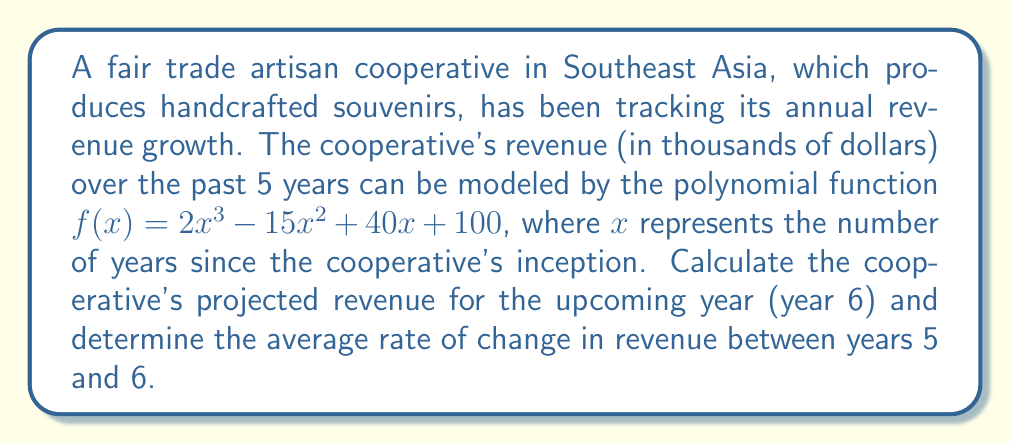Show me your answer to this math problem. 1) To find the revenue for year 6, we need to evaluate $f(6)$:

   $f(6) = 2(6)^3 - 15(6)^2 + 40(6) + 100$
   
   $= 2(216) - 15(36) + 40(6) + 100$
   
   $= 432 - 540 + 240 + 100$
   
   $= 232$

   So, the projected revenue for year 6 is $232,000.

2) To find the average rate of change between years 5 and 6, we use the formula:

   $$\text{Average rate of change} = \frac{f(6) - f(5)}{6 - 5}$$

3) We already calculated $f(6) = 232$. Now let's calculate $f(5)$:

   $f(5) = 2(5)^3 - 15(5)^2 + 40(5) + 100$
   
   $= 2(125) - 15(25) + 40(5) + 100$
   
   $= 250 - 375 + 200 + 100$
   
   $= 175$

4) Now we can calculate the average rate of change:

   $$\text{Average rate of change} = \frac{232 - 175}{6 - 5} = \frac{57}{1} = 57$$

Therefore, the average rate of change in revenue between years 5 and 6 is $57,000 per year.
Answer: $232,000; $57,000/year 